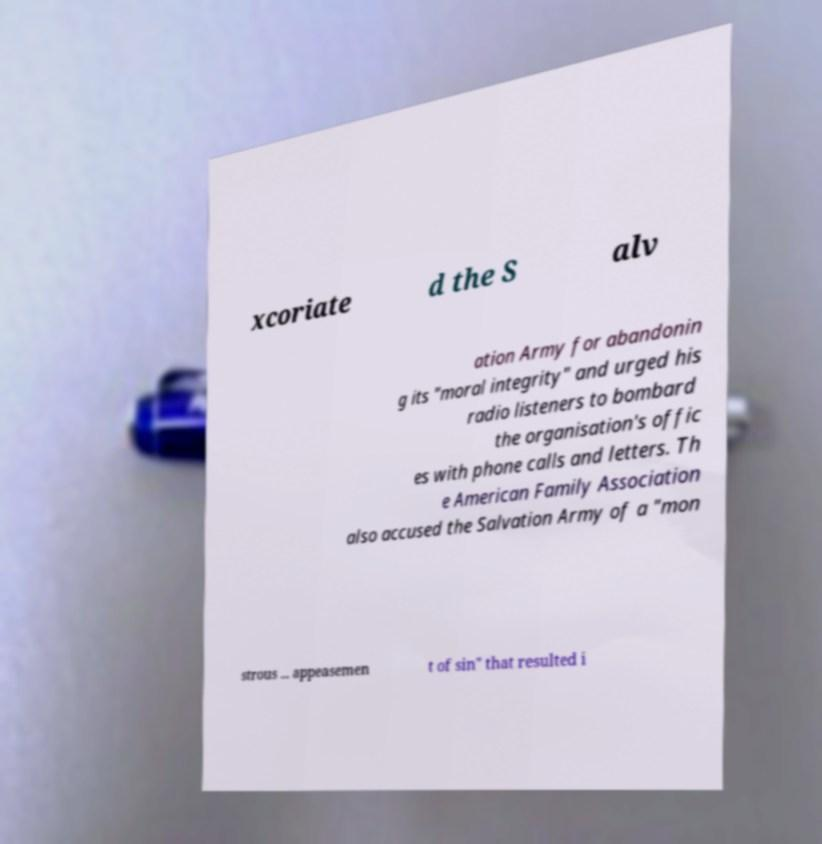Please identify and transcribe the text found in this image. xcoriate d the S alv ation Army for abandonin g its "moral integrity" and urged his radio listeners to bombard the organisation's offic es with phone calls and letters. Th e American Family Association also accused the Salvation Army of a "mon strous ... appeasemen t of sin" that resulted i 